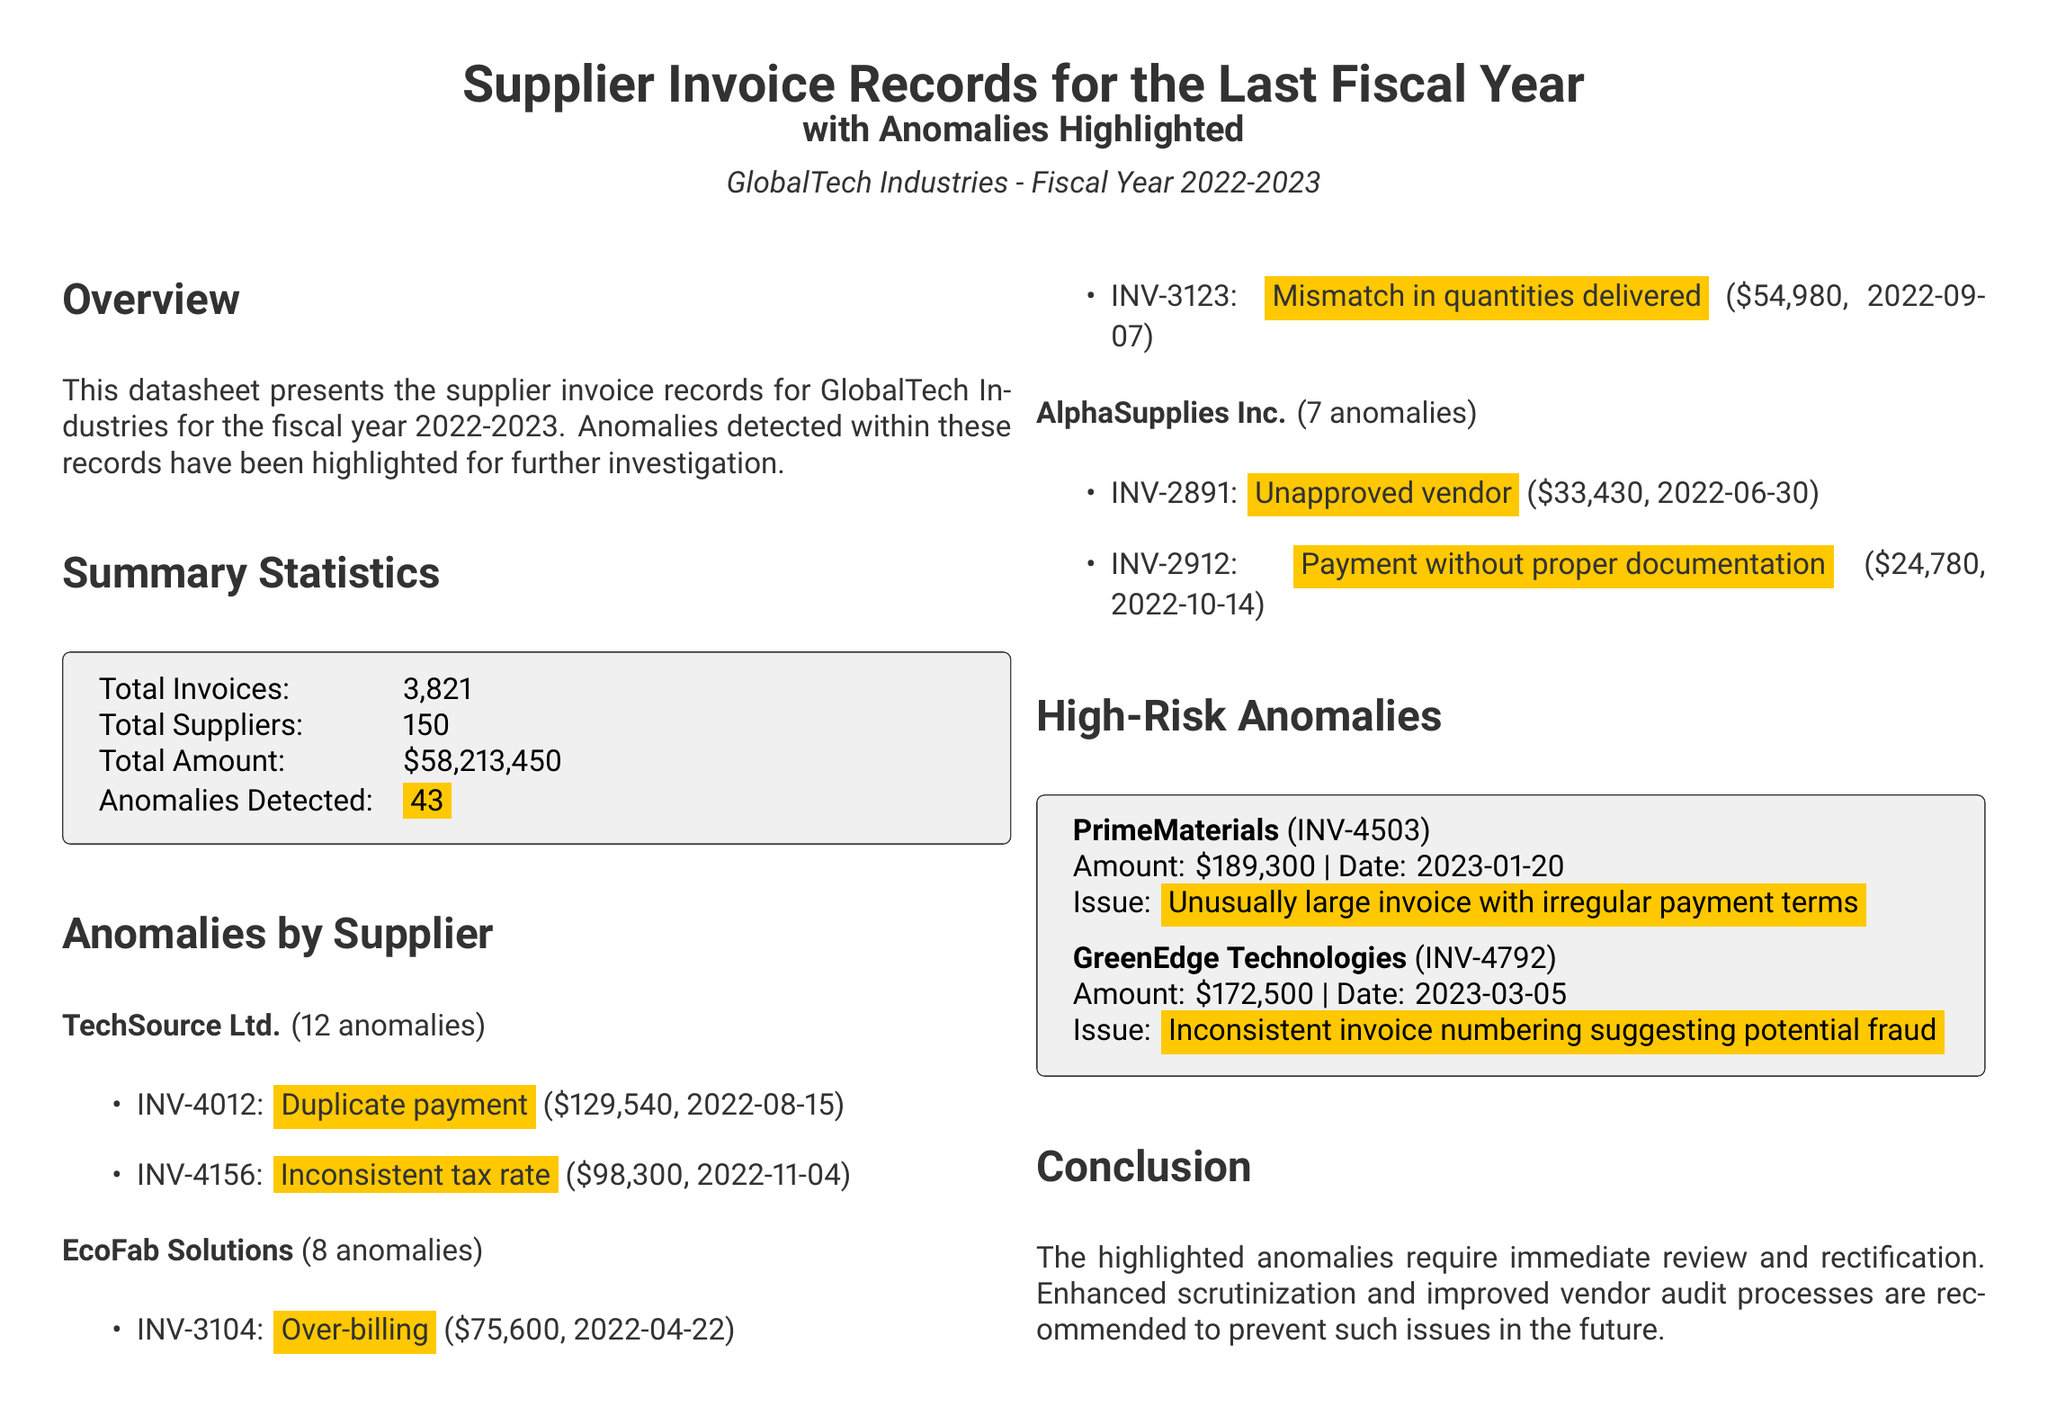what is the total number of invoices? The document states that the total number of invoices is listed in the summary statistics.
Answer: 3,821 how many anomalies were detected? The number of anomalies detected is recorded in the summary statistics section of the datasheet.
Answer: 43 which supplier had the most anomalies? The supplier with the highest count of anomalies is mentioned under "Anomalies by Supplier."
Answer: TechSource Ltd what is the amount of the invoice with the highest risk? The high-risk anomalies section provides the amounts of the corresponding invoices.
Answer: $189,300 what was the issue with the invoice INV-4503? The specific issue related to invoice INV-4503 is categorized under high-risk anomalies.
Answer: Unusually large invoice with irregular payment terms how many different suppliers are recorded? The total number of suppliers is noted in the summary statistics.
Answer: 150 what date was the invoice INV-4792 issued? The date of invoice INV-4792 is outlined in the high-risk anomalies section.
Answer: 2023-03-05 how many anomalies did EcoFab Solutions have? The count of anomalies for EcoFab Solutions can be found in the "Anomalies by Supplier" section.
Answer: 8 what type of anomaly was found in INV-2891? The anomaly for INV-2891 is explicitly described in the "Anomalies by Supplier" section.
Answer: Unapproved vendor 